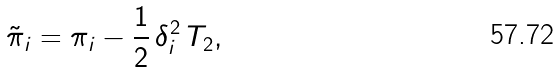<formula> <loc_0><loc_0><loc_500><loc_500>\tilde { \pi } _ { i } = \pi _ { i } - \frac { 1 } { 2 } \, \delta _ { i } ^ { 2 } \, T _ { 2 } ,</formula> 